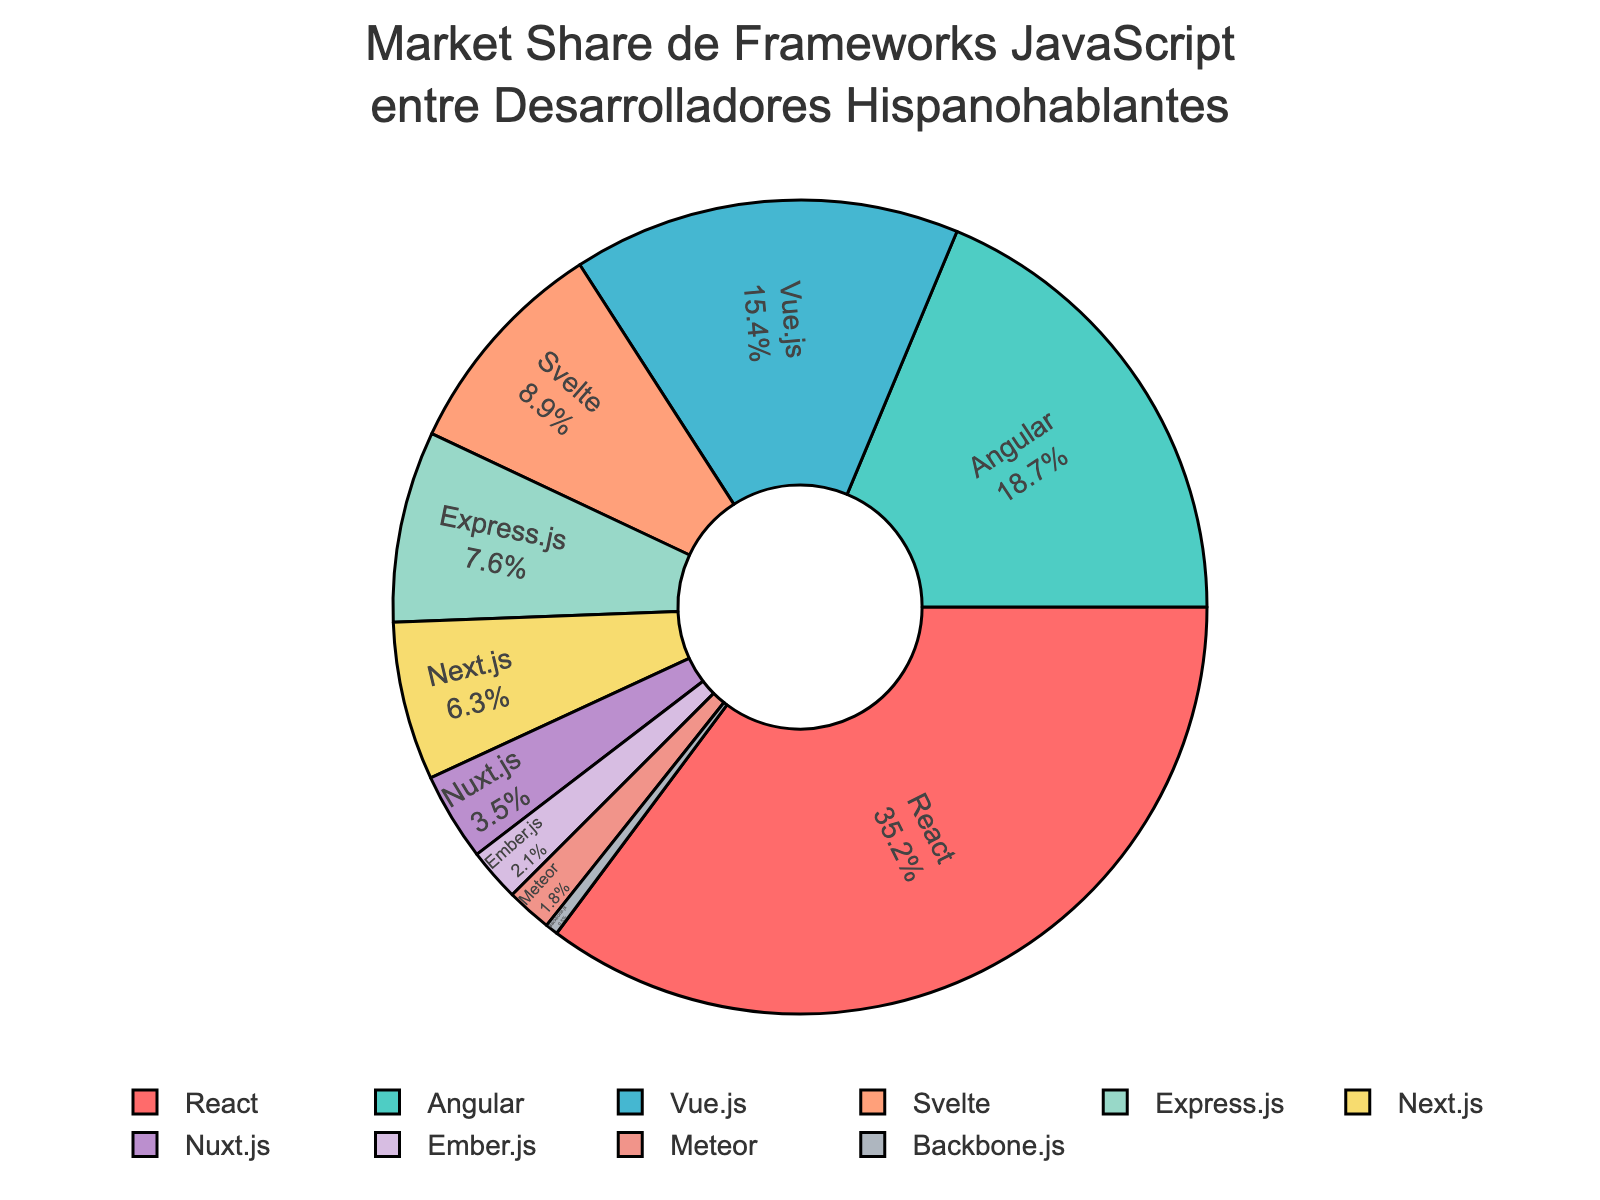¿Cuál es el framework de JavaScript más popular entre los desarrolladores hispanohablantes? El framework más popular es el que tiene el mayor porcentaje en el gráfico. Mirando el gráfico, React tiene el porcentaje más alto
Answer: React ¿Cuántos frameworks tienen una cuota de mercado mayor al 10%? Observamos los porcentajes en el gráfico y contamos cuántos son mayores a 10%. React (35.2%), Angular (18.7%), y Vue.js (15.4%) cumplen con esta condición
Answer: 3 ¿Qué porcentaje total suman Svelte y Express.js? Sumamos los porcentajes de Svelte (8.9%) y Express.js (7.6%). La suma es 8.9 + 7.6
Answer: 16.5% ¿Qué framework tiene un menor porcentaje que Nuxt.js pero mayor que Backbone.js? Observamos los porcentajes de Nuxt.js (3.5%) y Backbone.js (0.5%) y buscamos un framework con un valor entre estos dos. Meteor tiene un 1.8%
Answer: Meteor ¿Cuál es la diferencia de porcentaje entre Angular y Next.js? Restamos el porcentaje de Next.js (6.3%) al de Angular (18.7%). 18.7 - 6.3
Answer: 12.4 De los frameworks listados en el gráfico, ¿cuál tiene el color verde? Buscamos el framework con el color verde en el gráfico. Angular está representado en verde
Answer: Angular Si sumamos los porcentajes de Ember.js y Meteor, ¿supera al de Svelte? Sumamos los porcentajes de Ember.js (2.1%) y Meteor (1.8%) y comparamos con el de Svelte (8.9%). La suma es 2.1 + 1.8 = 3.9%, que es menor a 8.9%
Answer: No ¿Cuál es la diferencia de porcentaje entre el framework menos popular y el más popular? Restamos el porcentaje del framework menos popular, Backbone.js (0.5%) al del más popular, React (35.2%). 35.2 - 0.5
Answer: 34.7 ¿Qué frameworks juntos tienen un porcentaje total de al menos 20%? Seleccionamos frameworks cuyos porcentajes sumen al menos 20%. React (35.2%) ya supera el 20%, también Angular (18.7%) y Vue.js (15.4%) juntos (34.1%)
Answer: React, Angular y Vue.js 